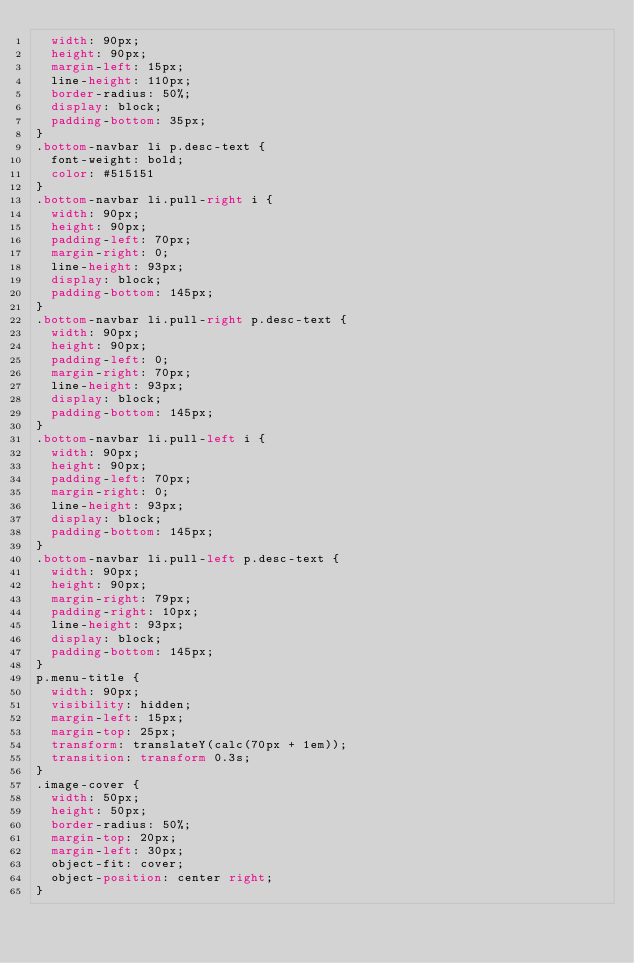Convert code to text. <code><loc_0><loc_0><loc_500><loc_500><_CSS_>  width: 90px;
  height: 90px;
  margin-left: 15px;
  line-height: 110px;
  border-radius: 50%;
  display: block;
  padding-bottom: 35px;
}
.bottom-navbar li p.desc-text {
  font-weight: bold;
  color: #515151
}
.bottom-navbar li.pull-right i {
  width: 90px;
  height: 90px;
  padding-left: 70px;
  margin-right: 0;
  line-height: 93px;
  display: block;
  padding-bottom: 145px;
}
.bottom-navbar li.pull-right p.desc-text {
  width: 90px;
  height: 90px;
  padding-left: 0;
  margin-right: 70px;
  line-height: 93px;
  display: block;
  padding-bottom: 145px;
}
.bottom-navbar li.pull-left i {
  width: 90px;
  height: 90px;
  padding-left: 70px;
  margin-right: 0;
  line-height: 93px;
  display: block;
  padding-bottom: 145px;
}
.bottom-navbar li.pull-left p.desc-text {
  width: 90px;
  height: 90px;
  margin-right: 79px;
  padding-right: 10px;
  line-height: 93px;
  display: block;
  padding-bottom: 145px;
}
p.menu-title {
  width: 90px;
  visibility: hidden;
  margin-left: 15px;
  margin-top: 25px;
  transform: translateY(calc(70px + 1em));
  transition: transform 0.3s;
}
.image-cover {
  width: 50px;
  height: 50px;
  border-radius: 50%;
  margin-top: 20px;
  margin-left: 30px;
  object-fit: cover;
  object-position: center right;
}</code> 